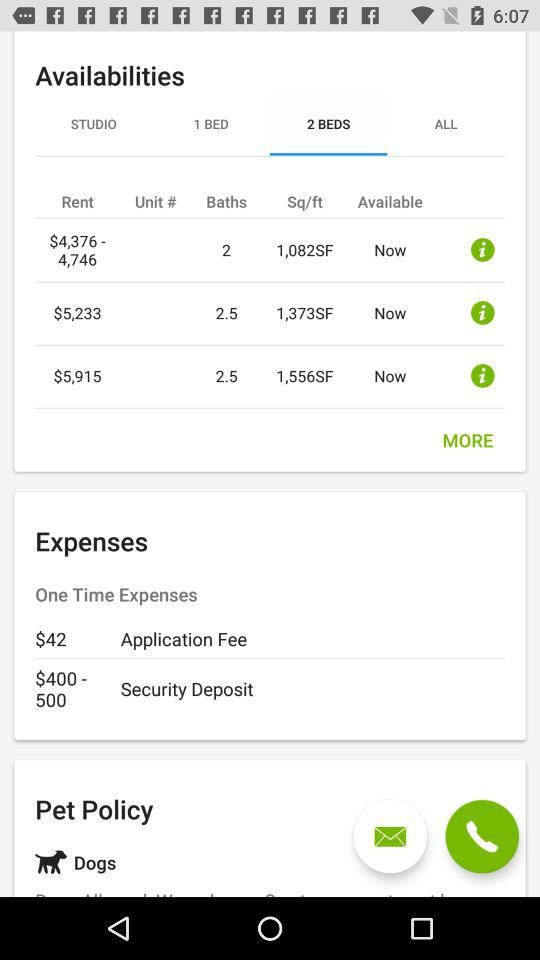What is the application fee? The application fee is $42. 